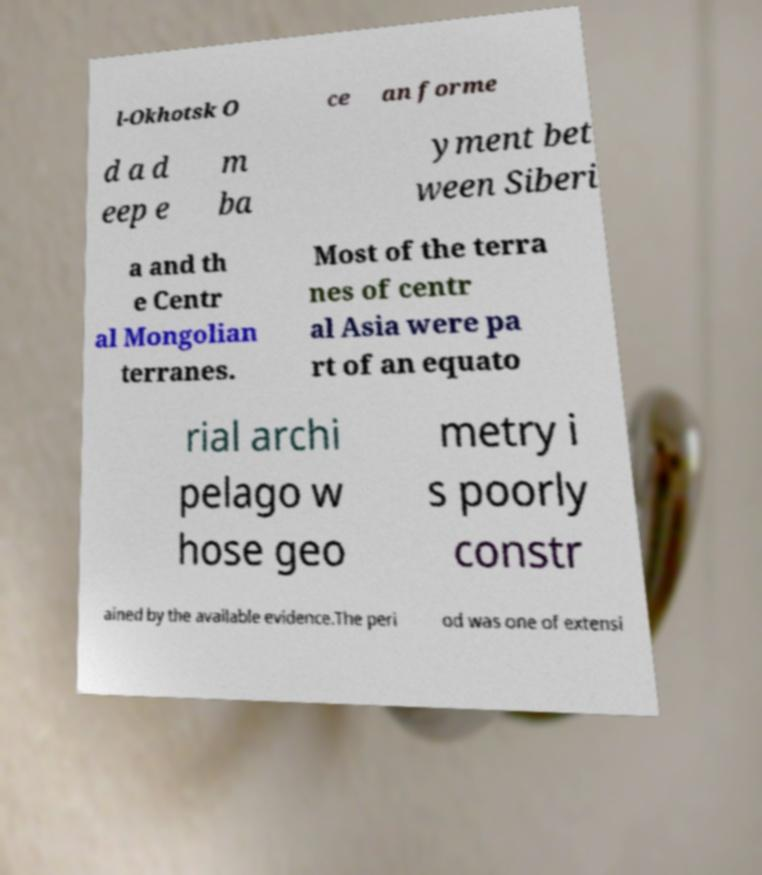There's text embedded in this image that I need extracted. Can you transcribe it verbatim? l-Okhotsk O ce an forme d a d eep e m ba yment bet ween Siberi a and th e Centr al Mongolian terranes. Most of the terra nes of centr al Asia were pa rt of an equato rial archi pelago w hose geo metry i s poorly constr ained by the available evidence.The peri od was one of extensi 